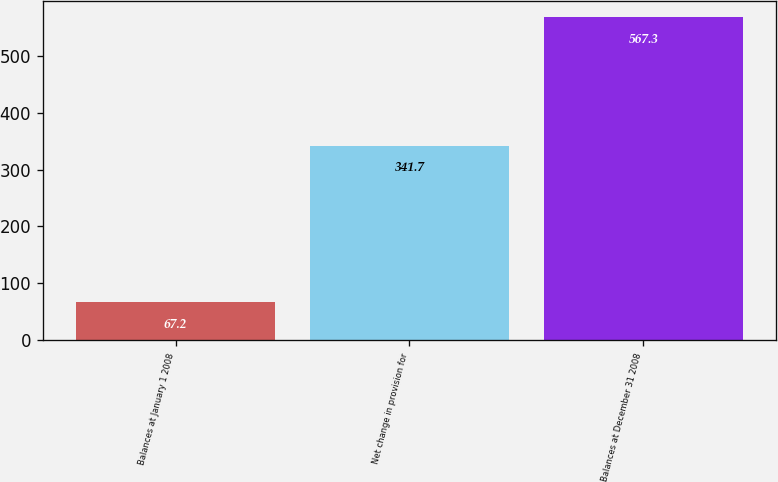Convert chart to OTSL. <chart><loc_0><loc_0><loc_500><loc_500><bar_chart><fcel>Balances at January 1 2008<fcel>Net change in provision for<fcel>Balances at December 31 2008<nl><fcel>67.2<fcel>341.7<fcel>567.3<nl></chart> 